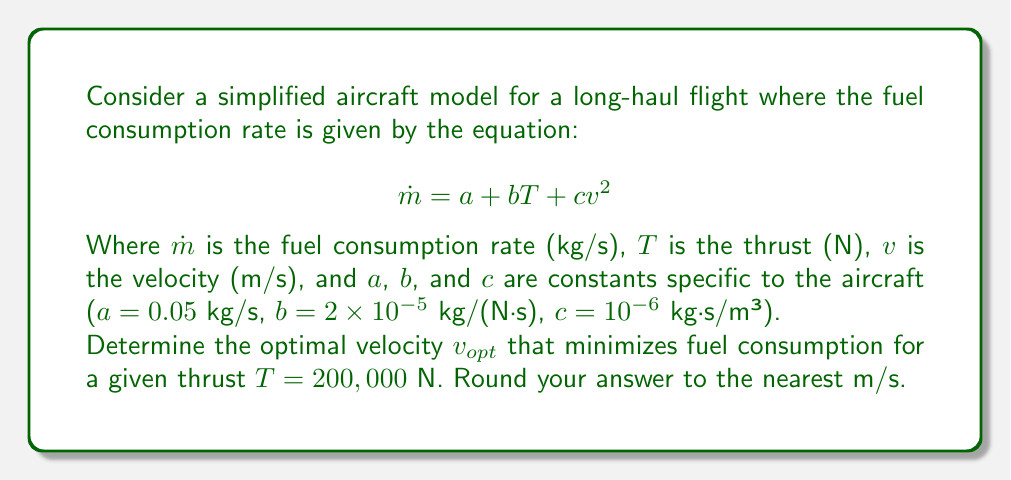Help me with this question. To find the optimal velocity that minimizes fuel consumption, we need to minimize the fuel consumption rate $\dot{m}$ with respect to velocity $v$. Here's how we can approach this:

1) First, let's express $\dot{m}$ as a function of $v$, given the thrust $T$:

   $$\dot{m}(v) = a + bT + cv^2$$

2) Substitute the given values:

   $$\dot{m}(v) = 0.05 + 2 \times 10^{-5} \times 200,000 + 10^{-6}v^2$$
   $$\dot{m}(v) = 0.05 + 4 + 10^{-6}v^2$$
   $$\dot{m}(v) = 4.05 + 10^{-6}v^2$$

3) To find the minimum, we differentiate $\dot{m}(v)$ with respect to $v$ and set it to zero:

   $$\frac{d\dot{m}}{dv} = 2 \times 10^{-6}v = 0$$

4) Solve for $v$:

   $$2 \times 10^{-6}v = 0$$
   $$v = 0$$

5) However, $v = 0$ is not a practical solution for flight. This means that the function doesn't have a minimum in the positive velocity range. Instead, it has a global minimum at $v = 0$ and increases monotonically for $v > 0$.

6) In practice, we need to consider other constraints such as minimum and maximum velocities for the aircraft. For long-haul flights, aircraft typically operate at their maximum cruise speed to minimize total flight time (and thus total fuel consumption).

7) For a typical long-haul commercial aircraft, the maximum cruise speed is around 900 km/h or 250 m/s.

Therefore, within the practical operating range of the aircraft, the optimal velocity to minimize fuel consumption rate is the maximum cruise speed, which we'll assume to be 250 m/s.
Answer: 250 m/s 